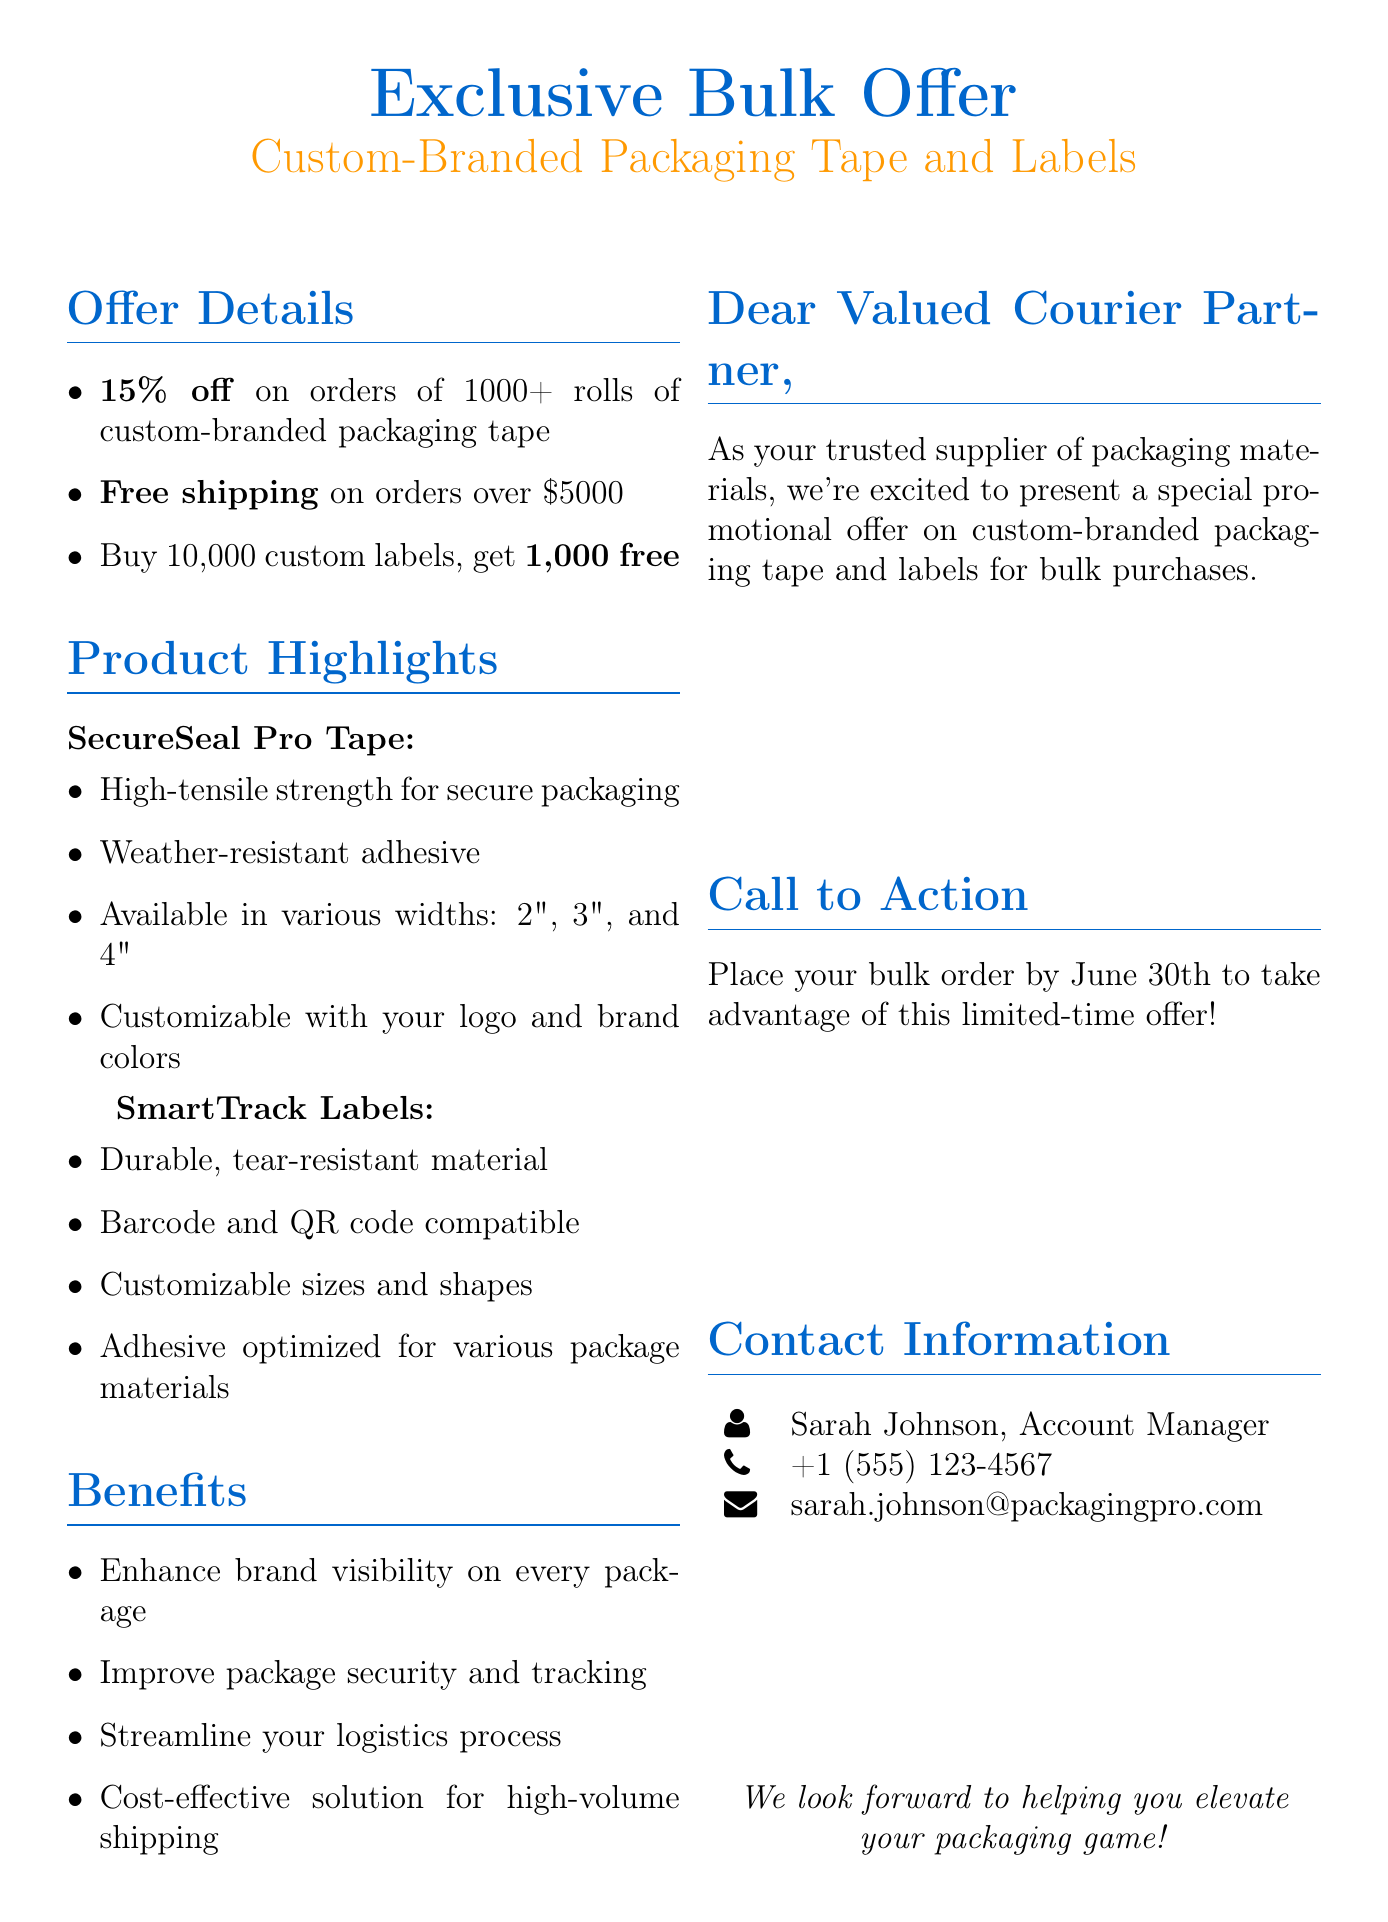What is the discount on bulk purchases? The discount is offered for orders of 1000 or more rolls of packaging tape.
Answer: 15% off What is the free shipping threshold? The free shipping applies to orders that exceed a specific amount.
Answer: $5000 How many free labels do you get when you buy 10,000? This is a promotional deal that offers additional labels for a bulk purchase of custom labels.
Answer: 1,000 free What is the brand name of the packaging tape? The brand is mentioned specifically in the document as part of the product highlights.
Answer: SecureSeal Pro Who is the account manager? The document provides the name and position of the individual to contact for more information.
Answer: Sarah Johnson What is one feature of SmartTrack Labels? One important characteristic highlights the compatibility of labels with certain technologies.
Answer: Barcode and QR code compatible What is the last date to place an order to avail the offer? The document specifies a deadline for taking advantage of the promotional offer on bulk purchases.
Answer: June 30th What is a benefit of custom-branded packaging? The document lists several advantages, one of which helps improve the visibility of the brand.
Answer: Enhance brand visibility What is the contact's phone number? The document includes the phone number for the account manager for inquiries.
Answer: +1 (555) 123-4567 